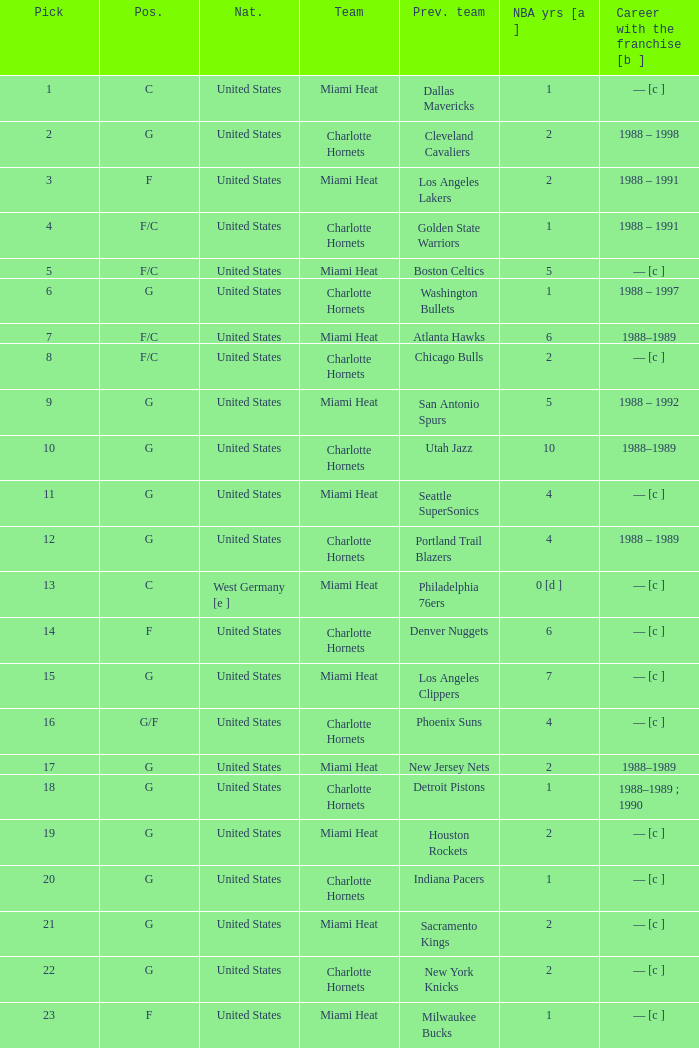What is the team of the player who was previously on the indiana pacers? Charlotte Hornets. 